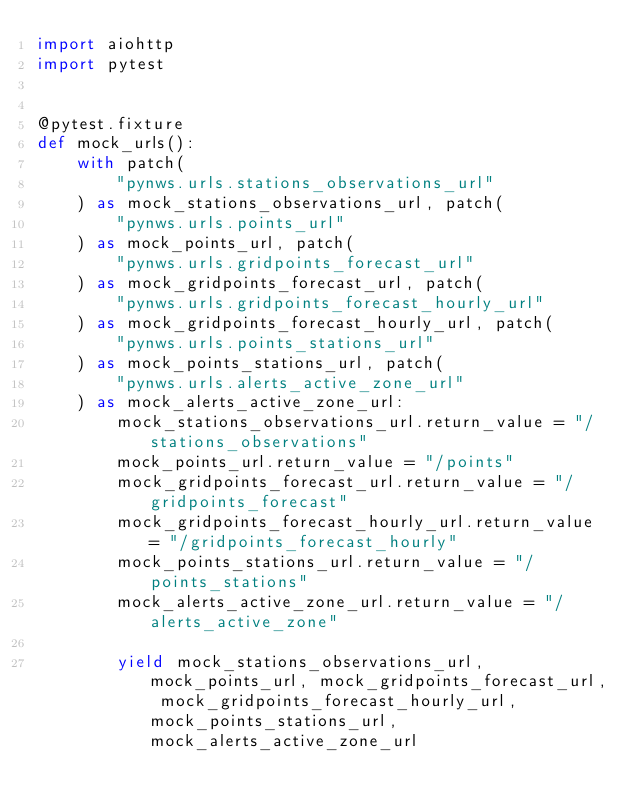<code> <loc_0><loc_0><loc_500><loc_500><_Python_>import aiohttp
import pytest


@pytest.fixture
def mock_urls():
    with patch(
        "pynws.urls.stations_observations_url"
    ) as mock_stations_observations_url, patch(
        "pynws.urls.points_url"
    ) as mock_points_url, patch(
        "pynws.urls.gridpoints_forecast_url"
    ) as mock_gridpoints_forecast_url, patch(
        "pynws.urls.gridpoints_forecast_hourly_url"
    ) as mock_gridpoints_forecast_hourly_url, patch(
        "pynws.urls.points_stations_url"
    ) as mock_points_stations_url, patch(
        "pynws.urls.alerts_active_zone_url"
    ) as mock_alerts_active_zone_url:
        mock_stations_observations_url.return_value = "/stations_observations"
        mock_points_url.return_value = "/points"
        mock_gridpoints_forecast_url.return_value = "/gridpoints_forecast"
        mock_gridpoints_forecast_hourly_url.return_value = "/gridpoints_forecast_hourly"
        mock_points_stations_url.return_value = "/points_stations"
        mock_alerts_active_zone_url.return_value = "/alerts_active_zone"

        yield mock_stations_observations_url, mock_points_url, mock_gridpoints_forecast_url, mock_gridpoints_forecast_hourly_url, mock_points_stations_url, mock_alerts_active_zone_url
</code> 